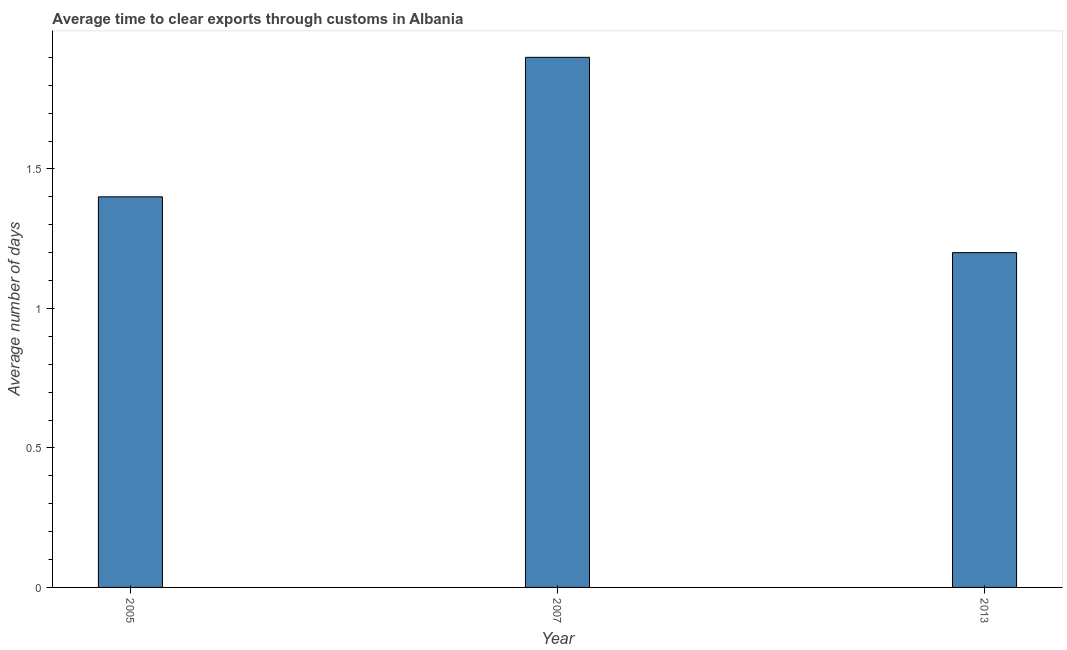Does the graph contain any zero values?
Provide a succinct answer. No. What is the title of the graph?
Make the answer very short. Average time to clear exports through customs in Albania. What is the label or title of the X-axis?
Keep it short and to the point. Year. What is the label or title of the Y-axis?
Your answer should be very brief. Average number of days. In which year was the time to clear exports through customs maximum?
Provide a short and direct response. 2007. In which year was the time to clear exports through customs minimum?
Offer a terse response. 2013. What is the difference between the time to clear exports through customs in 2007 and 2013?
Offer a very short reply. 0.7. What is the average time to clear exports through customs per year?
Your answer should be compact. 1.5. In how many years, is the time to clear exports through customs greater than 0.9 days?
Make the answer very short. 3. Do a majority of the years between 2013 and 2005 (inclusive) have time to clear exports through customs greater than 1.1 days?
Provide a succinct answer. Yes. What is the ratio of the time to clear exports through customs in 2007 to that in 2013?
Provide a succinct answer. 1.58. Is the difference between the time to clear exports through customs in 2007 and 2013 greater than the difference between any two years?
Your answer should be compact. Yes. Is the sum of the time to clear exports through customs in 2005 and 2007 greater than the maximum time to clear exports through customs across all years?
Keep it short and to the point. Yes. What is the difference between the highest and the lowest time to clear exports through customs?
Provide a succinct answer. 0.7. In how many years, is the time to clear exports through customs greater than the average time to clear exports through customs taken over all years?
Your answer should be very brief. 1. How many bars are there?
Offer a terse response. 3. Are all the bars in the graph horizontal?
Provide a succinct answer. No. Are the values on the major ticks of Y-axis written in scientific E-notation?
Ensure brevity in your answer.  No. What is the Average number of days in 2005?
Your answer should be very brief. 1.4. What is the Average number of days in 2007?
Give a very brief answer. 1.9. What is the difference between the Average number of days in 2005 and 2007?
Offer a very short reply. -0.5. What is the difference between the Average number of days in 2005 and 2013?
Your answer should be very brief. 0.2. What is the ratio of the Average number of days in 2005 to that in 2007?
Keep it short and to the point. 0.74. What is the ratio of the Average number of days in 2005 to that in 2013?
Offer a very short reply. 1.17. What is the ratio of the Average number of days in 2007 to that in 2013?
Your response must be concise. 1.58. 